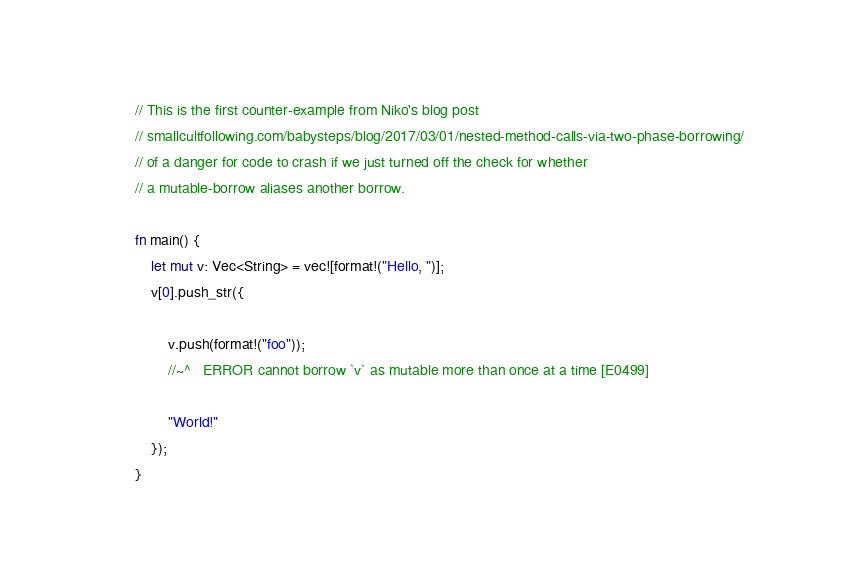Convert code to text. <code><loc_0><loc_0><loc_500><loc_500><_Rust_>// This is the first counter-example from Niko's blog post
// smallcultfollowing.com/babysteps/blog/2017/03/01/nested-method-calls-via-two-phase-borrowing/
// of a danger for code to crash if we just turned off the check for whether
// a mutable-borrow aliases another borrow.

fn main() {
    let mut v: Vec<String> = vec![format!("Hello, ")];
    v[0].push_str({

        v.push(format!("foo"));
        //~^   ERROR cannot borrow `v` as mutable more than once at a time [E0499]

        "World!"
    });
}
</code> 